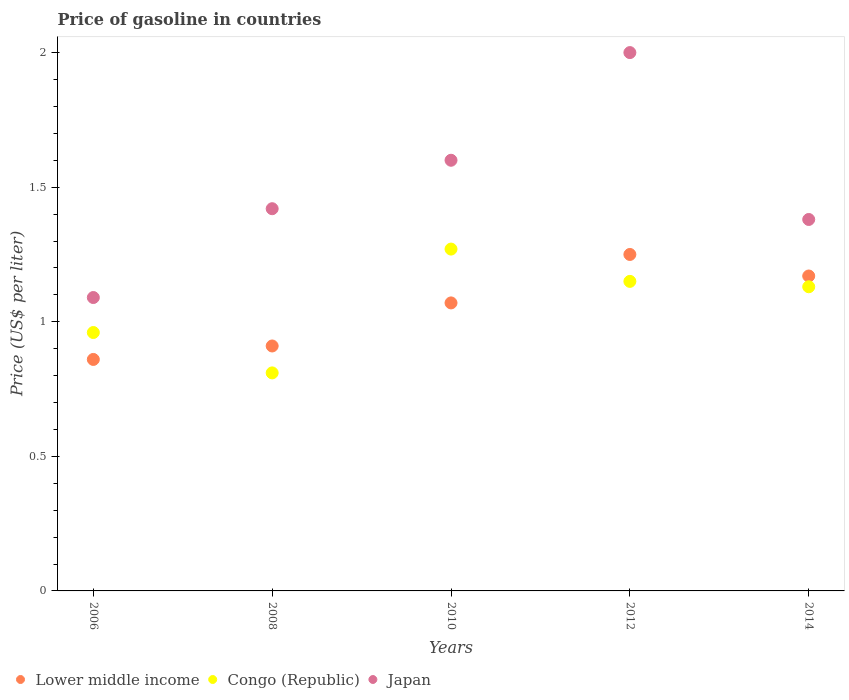What is the price of gasoline in Japan in 2014?
Ensure brevity in your answer.  1.38. Across all years, what is the minimum price of gasoline in Lower middle income?
Your answer should be compact. 0.86. In which year was the price of gasoline in Lower middle income maximum?
Your answer should be compact. 2012. In which year was the price of gasoline in Congo (Republic) minimum?
Make the answer very short. 2008. What is the total price of gasoline in Congo (Republic) in the graph?
Ensure brevity in your answer.  5.32. What is the difference between the price of gasoline in Japan in 2012 and that in 2014?
Ensure brevity in your answer.  0.62. What is the difference between the price of gasoline in Lower middle income in 2010 and the price of gasoline in Congo (Republic) in 2008?
Make the answer very short. 0.26. What is the average price of gasoline in Lower middle income per year?
Offer a very short reply. 1.05. In how many years, is the price of gasoline in Japan greater than 0.4 US$?
Give a very brief answer. 5. What is the ratio of the price of gasoline in Lower middle income in 2006 to that in 2012?
Your answer should be very brief. 0.69. Is the price of gasoline in Lower middle income in 2010 less than that in 2014?
Your answer should be compact. Yes. What is the difference between the highest and the second highest price of gasoline in Japan?
Offer a very short reply. 0.4. What is the difference between the highest and the lowest price of gasoline in Congo (Republic)?
Ensure brevity in your answer.  0.46. In how many years, is the price of gasoline in Congo (Republic) greater than the average price of gasoline in Congo (Republic) taken over all years?
Your answer should be compact. 3. Is the sum of the price of gasoline in Congo (Republic) in 2006 and 2008 greater than the maximum price of gasoline in Lower middle income across all years?
Your answer should be very brief. Yes. Is it the case that in every year, the sum of the price of gasoline in Lower middle income and price of gasoline in Congo (Republic)  is greater than the price of gasoline in Japan?
Keep it short and to the point. Yes. Does the price of gasoline in Congo (Republic) monotonically increase over the years?
Your answer should be very brief. No. Is the price of gasoline in Lower middle income strictly greater than the price of gasoline in Congo (Republic) over the years?
Your answer should be compact. No. How many years are there in the graph?
Your answer should be very brief. 5. Does the graph contain any zero values?
Give a very brief answer. No. How many legend labels are there?
Give a very brief answer. 3. How are the legend labels stacked?
Make the answer very short. Horizontal. What is the title of the graph?
Keep it short and to the point. Price of gasoline in countries. What is the label or title of the X-axis?
Your answer should be very brief. Years. What is the label or title of the Y-axis?
Your answer should be compact. Price (US$ per liter). What is the Price (US$ per liter) of Lower middle income in 2006?
Your response must be concise. 0.86. What is the Price (US$ per liter) of Japan in 2006?
Give a very brief answer. 1.09. What is the Price (US$ per liter) in Lower middle income in 2008?
Provide a succinct answer. 0.91. What is the Price (US$ per liter) in Congo (Republic) in 2008?
Ensure brevity in your answer.  0.81. What is the Price (US$ per liter) in Japan in 2008?
Offer a terse response. 1.42. What is the Price (US$ per liter) in Lower middle income in 2010?
Give a very brief answer. 1.07. What is the Price (US$ per liter) in Congo (Republic) in 2010?
Your response must be concise. 1.27. What is the Price (US$ per liter) of Japan in 2010?
Your answer should be very brief. 1.6. What is the Price (US$ per liter) of Congo (Republic) in 2012?
Your answer should be compact. 1.15. What is the Price (US$ per liter) in Lower middle income in 2014?
Your answer should be very brief. 1.17. What is the Price (US$ per liter) in Congo (Republic) in 2014?
Give a very brief answer. 1.13. What is the Price (US$ per liter) in Japan in 2014?
Provide a succinct answer. 1.38. Across all years, what is the maximum Price (US$ per liter) of Lower middle income?
Give a very brief answer. 1.25. Across all years, what is the maximum Price (US$ per liter) in Congo (Republic)?
Your response must be concise. 1.27. Across all years, what is the minimum Price (US$ per liter) of Lower middle income?
Your answer should be very brief. 0.86. Across all years, what is the minimum Price (US$ per liter) of Congo (Republic)?
Keep it short and to the point. 0.81. Across all years, what is the minimum Price (US$ per liter) in Japan?
Your answer should be very brief. 1.09. What is the total Price (US$ per liter) in Lower middle income in the graph?
Offer a very short reply. 5.26. What is the total Price (US$ per liter) in Congo (Republic) in the graph?
Offer a very short reply. 5.32. What is the total Price (US$ per liter) in Japan in the graph?
Offer a terse response. 7.49. What is the difference between the Price (US$ per liter) of Lower middle income in 2006 and that in 2008?
Give a very brief answer. -0.05. What is the difference between the Price (US$ per liter) in Congo (Republic) in 2006 and that in 2008?
Keep it short and to the point. 0.15. What is the difference between the Price (US$ per liter) of Japan in 2006 and that in 2008?
Your response must be concise. -0.33. What is the difference between the Price (US$ per liter) in Lower middle income in 2006 and that in 2010?
Your response must be concise. -0.21. What is the difference between the Price (US$ per liter) in Congo (Republic) in 2006 and that in 2010?
Provide a succinct answer. -0.31. What is the difference between the Price (US$ per liter) of Japan in 2006 and that in 2010?
Your answer should be very brief. -0.51. What is the difference between the Price (US$ per liter) of Lower middle income in 2006 and that in 2012?
Provide a short and direct response. -0.39. What is the difference between the Price (US$ per liter) of Congo (Republic) in 2006 and that in 2012?
Give a very brief answer. -0.19. What is the difference between the Price (US$ per liter) in Japan in 2006 and that in 2012?
Keep it short and to the point. -0.91. What is the difference between the Price (US$ per liter) of Lower middle income in 2006 and that in 2014?
Make the answer very short. -0.31. What is the difference between the Price (US$ per liter) of Congo (Republic) in 2006 and that in 2014?
Offer a very short reply. -0.17. What is the difference between the Price (US$ per liter) in Japan in 2006 and that in 2014?
Provide a short and direct response. -0.29. What is the difference between the Price (US$ per liter) of Lower middle income in 2008 and that in 2010?
Keep it short and to the point. -0.16. What is the difference between the Price (US$ per liter) in Congo (Republic) in 2008 and that in 2010?
Your response must be concise. -0.46. What is the difference between the Price (US$ per liter) in Japan in 2008 and that in 2010?
Give a very brief answer. -0.18. What is the difference between the Price (US$ per liter) in Lower middle income in 2008 and that in 2012?
Ensure brevity in your answer.  -0.34. What is the difference between the Price (US$ per liter) in Congo (Republic) in 2008 and that in 2012?
Your response must be concise. -0.34. What is the difference between the Price (US$ per liter) in Japan in 2008 and that in 2012?
Your answer should be compact. -0.58. What is the difference between the Price (US$ per liter) in Lower middle income in 2008 and that in 2014?
Give a very brief answer. -0.26. What is the difference between the Price (US$ per liter) in Congo (Republic) in 2008 and that in 2014?
Offer a very short reply. -0.32. What is the difference between the Price (US$ per liter) of Lower middle income in 2010 and that in 2012?
Your answer should be very brief. -0.18. What is the difference between the Price (US$ per liter) in Congo (Republic) in 2010 and that in 2012?
Provide a short and direct response. 0.12. What is the difference between the Price (US$ per liter) of Congo (Republic) in 2010 and that in 2014?
Your answer should be compact. 0.14. What is the difference between the Price (US$ per liter) in Japan in 2010 and that in 2014?
Provide a short and direct response. 0.22. What is the difference between the Price (US$ per liter) of Lower middle income in 2012 and that in 2014?
Provide a succinct answer. 0.08. What is the difference between the Price (US$ per liter) of Japan in 2012 and that in 2014?
Provide a short and direct response. 0.62. What is the difference between the Price (US$ per liter) of Lower middle income in 2006 and the Price (US$ per liter) of Japan in 2008?
Keep it short and to the point. -0.56. What is the difference between the Price (US$ per liter) in Congo (Republic) in 2006 and the Price (US$ per liter) in Japan in 2008?
Ensure brevity in your answer.  -0.46. What is the difference between the Price (US$ per liter) in Lower middle income in 2006 and the Price (US$ per liter) in Congo (Republic) in 2010?
Give a very brief answer. -0.41. What is the difference between the Price (US$ per liter) of Lower middle income in 2006 and the Price (US$ per liter) of Japan in 2010?
Make the answer very short. -0.74. What is the difference between the Price (US$ per liter) in Congo (Republic) in 2006 and the Price (US$ per liter) in Japan in 2010?
Your response must be concise. -0.64. What is the difference between the Price (US$ per liter) in Lower middle income in 2006 and the Price (US$ per liter) in Congo (Republic) in 2012?
Provide a succinct answer. -0.29. What is the difference between the Price (US$ per liter) in Lower middle income in 2006 and the Price (US$ per liter) in Japan in 2012?
Make the answer very short. -1.14. What is the difference between the Price (US$ per liter) of Congo (Republic) in 2006 and the Price (US$ per liter) of Japan in 2012?
Offer a terse response. -1.04. What is the difference between the Price (US$ per liter) of Lower middle income in 2006 and the Price (US$ per liter) of Congo (Republic) in 2014?
Provide a succinct answer. -0.27. What is the difference between the Price (US$ per liter) of Lower middle income in 2006 and the Price (US$ per liter) of Japan in 2014?
Ensure brevity in your answer.  -0.52. What is the difference between the Price (US$ per liter) of Congo (Republic) in 2006 and the Price (US$ per liter) of Japan in 2014?
Your answer should be very brief. -0.42. What is the difference between the Price (US$ per liter) of Lower middle income in 2008 and the Price (US$ per liter) of Congo (Republic) in 2010?
Keep it short and to the point. -0.36. What is the difference between the Price (US$ per liter) in Lower middle income in 2008 and the Price (US$ per liter) in Japan in 2010?
Give a very brief answer. -0.69. What is the difference between the Price (US$ per liter) of Congo (Republic) in 2008 and the Price (US$ per liter) of Japan in 2010?
Offer a very short reply. -0.79. What is the difference between the Price (US$ per liter) of Lower middle income in 2008 and the Price (US$ per liter) of Congo (Republic) in 2012?
Give a very brief answer. -0.24. What is the difference between the Price (US$ per liter) of Lower middle income in 2008 and the Price (US$ per liter) of Japan in 2012?
Your response must be concise. -1.09. What is the difference between the Price (US$ per liter) in Congo (Republic) in 2008 and the Price (US$ per liter) in Japan in 2012?
Ensure brevity in your answer.  -1.19. What is the difference between the Price (US$ per liter) of Lower middle income in 2008 and the Price (US$ per liter) of Congo (Republic) in 2014?
Your answer should be compact. -0.22. What is the difference between the Price (US$ per liter) of Lower middle income in 2008 and the Price (US$ per liter) of Japan in 2014?
Your answer should be compact. -0.47. What is the difference between the Price (US$ per liter) of Congo (Republic) in 2008 and the Price (US$ per liter) of Japan in 2014?
Give a very brief answer. -0.57. What is the difference between the Price (US$ per liter) of Lower middle income in 2010 and the Price (US$ per liter) of Congo (Republic) in 2012?
Ensure brevity in your answer.  -0.08. What is the difference between the Price (US$ per liter) in Lower middle income in 2010 and the Price (US$ per liter) in Japan in 2012?
Ensure brevity in your answer.  -0.93. What is the difference between the Price (US$ per liter) in Congo (Republic) in 2010 and the Price (US$ per liter) in Japan in 2012?
Offer a very short reply. -0.73. What is the difference between the Price (US$ per liter) in Lower middle income in 2010 and the Price (US$ per liter) in Congo (Republic) in 2014?
Offer a very short reply. -0.06. What is the difference between the Price (US$ per liter) of Lower middle income in 2010 and the Price (US$ per liter) of Japan in 2014?
Provide a succinct answer. -0.31. What is the difference between the Price (US$ per liter) of Congo (Republic) in 2010 and the Price (US$ per liter) of Japan in 2014?
Give a very brief answer. -0.11. What is the difference between the Price (US$ per liter) in Lower middle income in 2012 and the Price (US$ per liter) in Congo (Republic) in 2014?
Give a very brief answer. 0.12. What is the difference between the Price (US$ per liter) in Lower middle income in 2012 and the Price (US$ per liter) in Japan in 2014?
Offer a very short reply. -0.13. What is the difference between the Price (US$ per liter) of Congo (Republic) in 2012 and the Price (US$ per liter) of Japan in 2014?
Your response must be concise. -0.23. What is the average Price (US$ per liter) of Lower middle income per year?
Give a very brief answer. 1.05. What is the average Price (US$ per liter) of Congo (Republic) per year?
Offer a terse response. 1.06. What is the average Price (US$ per liter) of Japan per year?
Offer a very short reply. 1.5. In the year 2006, what is the difference between the Price (US$ per liter) of Lower middle income and Price (US$ per liter) of Congo (Republic)?
Offer a terse response. -0.1. In the year 2006, what is the difference between the Price (US$ per liter) in Lower middle income and Price (US$ per liter) in Japan?
Give a very brief answer. -0.23. In the year 2006, what is the difference between the Price (US$ per liter) in Congo (Republic) and Price (US$ per liter) in Japan?
Give a very brief answer. -0.13. In the year 2008, what is the difference between the Price (US$ per liter) in Lower middle income and Price (US$ per liter) in Japan?
Your response must be concise. -0.51. In the year 2008, what is the difference between the Price (US$ per liter) in Congo (Republic) and Price (US$ per liter) in Japan?
Your answer should be very brief. -0.61. In the year 2010, what is the difference between the Price (US$ per liter) in Lower middle income and Price (US$ per liter) in Congo (Republic)?
Offer a terse response. -0.2. In the year 2010, what is the difference between the Price (US$ per liter) in Lower middle income and Price (US$ per liter) in Japan?
Your answer should be compact. -0.53. In the year 2010, what is the difference between the Price (US$ per liter) of Congo (Republic) and Price (US$ per liter) of Japan?
Offer a terse response. -0.33. In the year 2012, what is the difference between the Price (US$ per liter) of Lower middle income and Price (US$ per liter) of Congo (Republic)?
Provide a short and direct response. 0.1. In the year 2012, what is the difference between the Price (US$ per liter) in Lower middle income and Price (US$ per liter) in Japan?
Make the answer very short. -0.75. In the year 2012, what is the difference between the Price (US$ per liter) of Congo (Republic) and Price (US$ per liter) of Japan?
Your answer should be compact. -0.85. In the year 2014, what is the difference between the Price (US$ per liter) of Lower middle income and Price (US$ per liter) of Congo (Republic)?
Provide a short and direct response. 0.04. In the year 2014, what is the difference between the Price (US$ per liter) in Lower middle income and Price (US$ per liter) in Japan?
Make the answer very short. -0.21. What is the ratio of the Price (US$ per liter) of Lower middle income in 2006 to that in 2008?
Provide a short and direct response. 0.95. What is the ratio of the Price (US$ per liter) of Congo (Republic) in 2006 to that in 2008?
Make the answer very short. 1.19. What is the ratio of the Price (US$ per liter) of Japan in 2006 to that in 2008?
Provide a succinct answer. 0.77. What is the ratio of the Price (US$ per liter) in Lower middle income in 2006 to that in 2010?
Offer a very short reply. 0.8. What is the ratio of the Price (US$ per liter) in Congo (Republic) in 2006 to that in 2010?
Provide a short and direct response. 0.76. What is the ratio of the Price (US$ per liter) in Japan in 2006 to that in 2010?
Make the answer very short. 0.68. What is the ratio of the Price (US$ per liter) in Lower middle income in 2006 to that in 2012?
Give a very brief answer. 0.69. What is the ratio of the Price (US$ per liter) of Congo (Republic) in 2006 to that in 2012?
Your answer should be compact. 0.83. What is the ratio of the Price (US$ per liter) in Japan in 2006 to that in 2012?
Keep it short and to the point. 0.55. What is the ratio of the Price (US$ per liter) in Lower middle income in 2006 to that in 2014?
Offer a very short reply. 0.73. What is the ratio of the Price (US$ per liter) of Congo (Republic) in 2006 to that in 2014?
Your answer should be very brief. 0.85. What is the ratio of the Price (US$ per liter) of Japan in 2006 to that in 2014?
Your answer should be compact. 0.79. What is the ratio of the Price (US$ per liter) in Lower middle income in 2008 to that in 2010?
Ensure brevity in your answer.  0.85. What is the ratio of the Price (US$ per liter) in Congo (Republic) in 2008 to that in 2010?
Your answer should be compact. 0.64. What is the ratio of the Price (US$ per liter) in Japan in 2008 to that in 2010?
Make the answer very short. 0.89. What is the ratio of the Price (US$ per liter) of Lower middle income in 2008 to that in 2012?
Your answer should be compact. 0.73. What is the ratio of the Price (US$ per liter) of Congo (Republic) in 2008 to that in 2012?
Make the answer very short. 0.7. What is the ratio of the Price (US$ per liter) in Japan in 2008 to that in 2012?
Provide a succinct answer. 0.71. What is the ratio of the Price (US$ per liter) of Lower middle income in 2008 to that in 2014?
Your response must be concise. 0.78. What is the ratio of the Price (US$ per liter) of Congo (Republic) in 2008 to that in 2014?
Give a very brief answer. 0.72. What is the ratio of the Price (US$ per liter) in Japan in 2008 to that in 2014?
Keep it short and to the point. 1.03. What is the ratio of the Price (US$ per liter) in Lower middle income in 2010 to that in 2012?
Your response must be concise. 0.86. What is the ratio of the Price (US$ per liter) in Congo (Republic) in 2010 to that in 2012?
Keep it short and to the point. 1.1. What is the ratio of the Price (US$ per liter) in Japan in 2010 to that in 2012?
Your answer should be very brief. 0.8. What is the ratio of the Price (US$ per liter) in Lower middle income in 2010 to that in 2014?
Your answer should be very brief. 0.91. What is the ratio of the Price (US$ per liter) in Congo (Republic) in 2010 to that in 2014?
Keep it short and to the point. 1.12. What is the ratio of the Price (US$ per liter) of Japan in 2010 to that in 2014?
Give a very brief answer. 1.16. What is the ratio of the Price (US$ per liter) of Lower middle income in 2012 to that in 2014?
Provide a succinct answer. 1.07. What is the ratio of the Price (US$ per liter) in Congo (Republic) in 2012 to that in 2014?
Keep it short and to the point. 1.02. What is the ratio of the Price (US$ per liter) of Japan in 2012 to that in 2014?
Offer a very short reply. 1.45. What is the difference between the highest and the second highest Price (US$ per liter) of Congo (Republic)?
Provide a short and direct response. 0.12. What is the difference between the highest and the second highest Price (US$ per liter) of Japan?
Provide a short and direct response. 0.4. What is the difference between the highest and the lowest Price (US$ per liter) of Lower middle income?
Offer a terse response. 0.39. What is the difference between the highest and the lowest Price (US$ per liter) of Congo (Republic)?
Provide a succinct answer. 0.46. What is the difference between the highest and the lowest Price (US$ per liter) in Japan?
Provide a short and direct response. 0.91. 